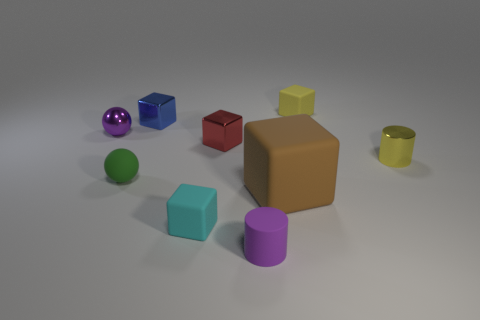Subtract all red blocks. How many blocks are left? 4 Subtract all tiny cyan matte blocks. How many blocks are left? 4 Subtract all purple blocks. Subtract all purple spheres. How many blocks are left? 5 Add 1 blue cubes. How many objects exist? 10 Subtract all cubes. How many objects are left? 4 Add 8 red metal objects. How many red metal objects are left? 9 Add 4 large blue metal cylinders. How many large blue metal cylinders exist? 4 Subtract 1 cyan cubes. How many objects are left? 8 Subtract all large blue rubber cubes. Subtract all small blue metal cubes. How many objects are left? 8 